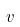Convert formula to latex. <formula><loc_0><loc_0><loc_500><loc_500>v</formula> 